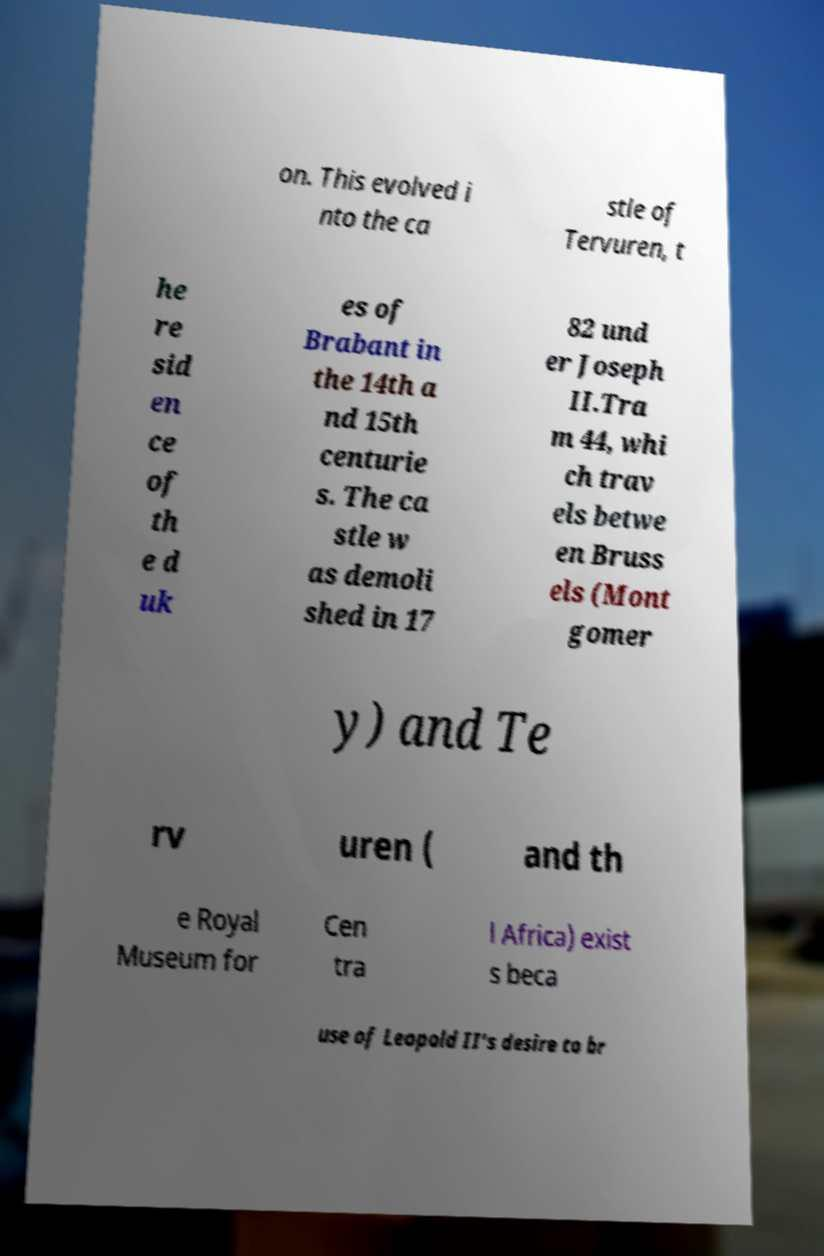I need the written content from this picture converted into text. Can you do that? on. This evolved i nto the ca stle of Tervuren, t he re sid en ce of th e d uk es of Brabant in the 14th a nd 15th centurie s. The ca stle w as demoli shed in 17 82 und er Joseph II.Tra m 44, whi ch trav els betwe en Bruss els (Mont gomer y) and Te rv uren ( and th e Royal Museum for Cen tra l Africa) exist s beca use of Leopold II's desire to br 